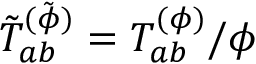<formula> <loc_0><loc_0><loc_500><loc_500>\tilde { T } _ { a b } ^ { ( \tilde { \phi } ) } = T _ { a b } ^ { ( \phi ) } / \phi</formula> 